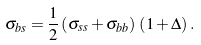Convert formula to latex. <formula><loc_0><loc_0><loc_500><loc_500>\sigma _ { b s } = \frac { 1 } { 2 } \left ( \sigma _ { s s } + \sigma _ { b b } \right ) \, \left ( 1 + \Delta \right ) .</formula> 